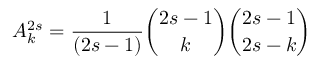<formula> <loc_0><loc_0><loc_500><loc_500>A _ { k } ^ { 2 s } = { \frac { 1 } { ( 2 s - 1 ) } } { \binom { 2 s - 1 } { k } } { \binom { 2 s - 1 } { 2 s - k } }</formula> 